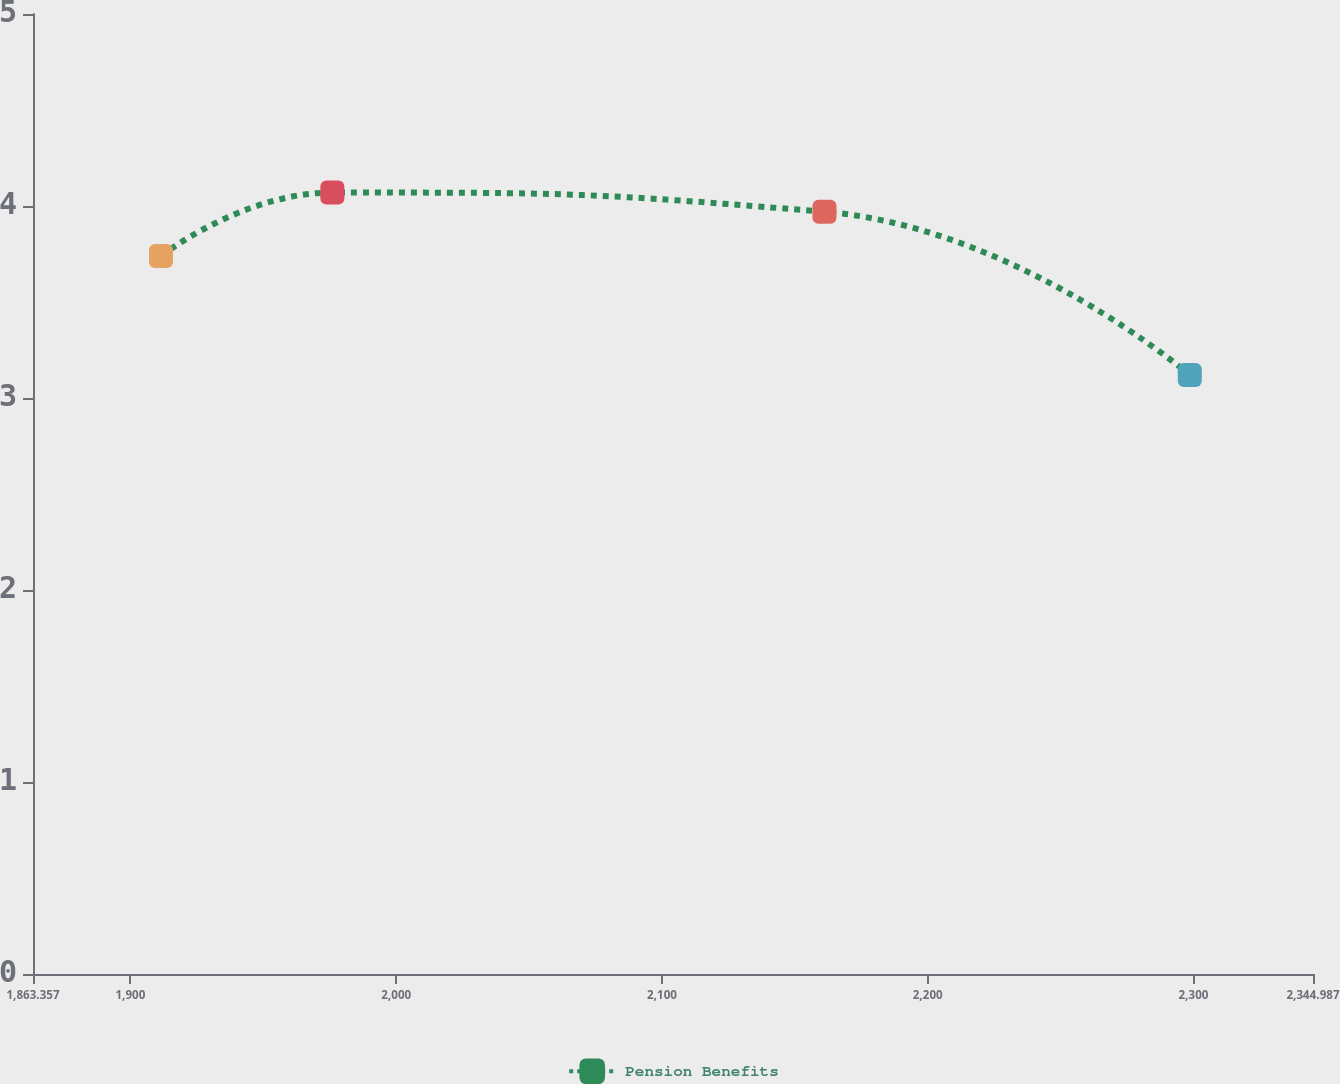Convert chart. <chart><loc_0><loc_0><loc_500><loc_500><line_chart><ecel><fcel>Pension Benefits<nl><fcel>1911.52<fcel>3.74<nl><fcel>1976<fcel>4.07<nl><fcel>2161.17<fcel>3.97<nl><fcel>2298.62<fcel>3.12<nl><fcel>2393.15<fcel>3.57<nl></chart> 